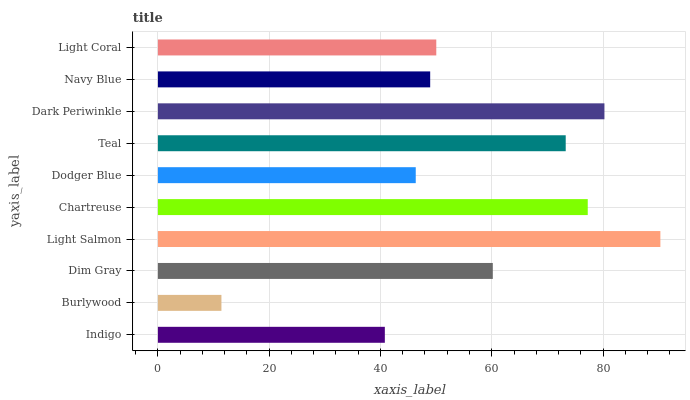Is Burlywood the minimum?
Answer yes or no. Yes. Is Light Salmon the maximum?
Answer yes or no. Yes. Is Dim Gray the minimum?
Answer yes or no. No. Is Dim Gray the maximum?
Answer yes or no. No. Is Dim Gray greater than Burlywood?
Answer yes or no. Yes. Is Burlywood less than Dim Gray?
Answer yes or no. Yes. Is Burlywood greater than Dim Gray?
Answer yes or no. No. Is Dim Gray less than Burlywood?
Answer yes or no. No. Is Dim Gray the high median?
Answer yes or no. Yes. Is Light Coral the low median?
Answer yes or no. Yes. Is Indigo the high median?
Answer yes or no. No. Is Dim Gray the low median?
Answer yes or no. No. 